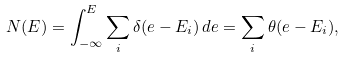<formula> <loc_0><loc_0><loc_500><loc_500>N ( E ) = \int _ { - \infty } ^ { E } \sum _ { i } \delta ( e - E _ { i } ) \, d e = \sum _ { i } \theta ( e - E _ { i } ) ,</formula> 